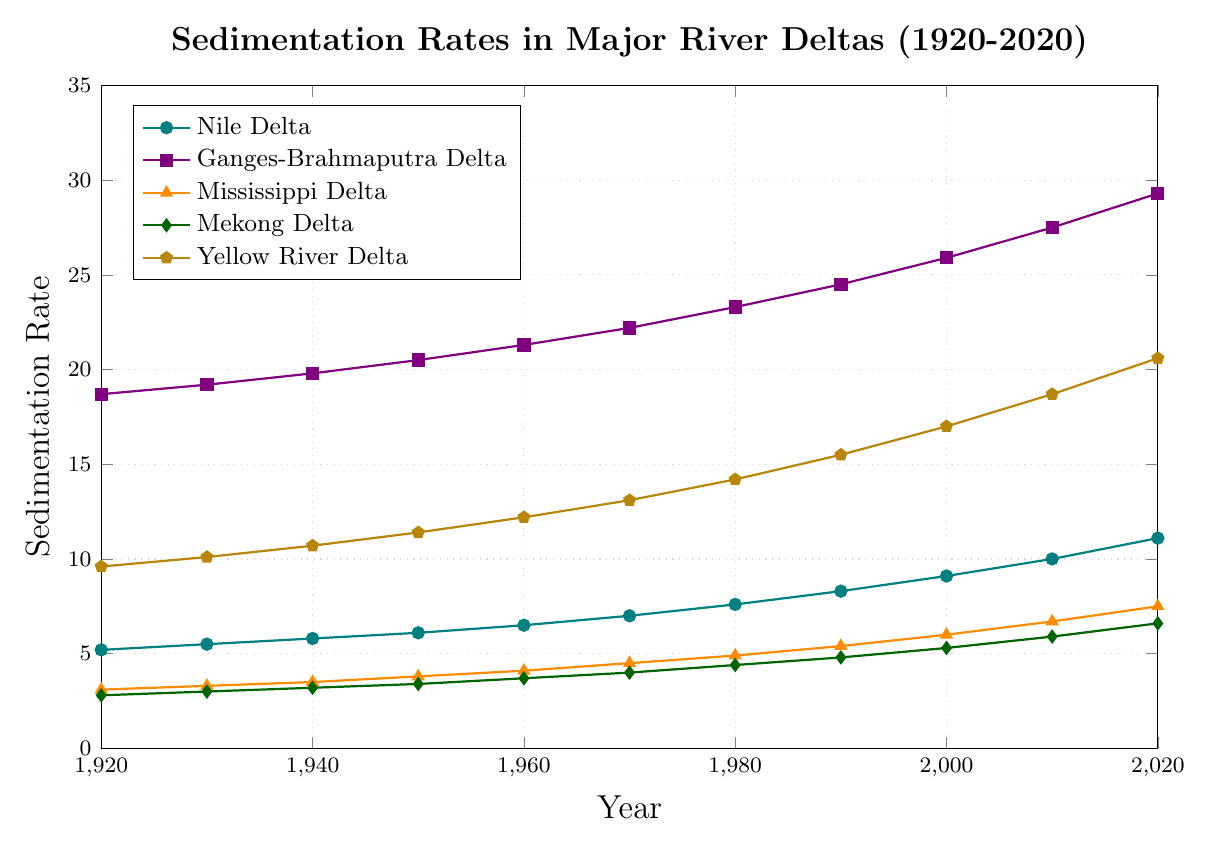Which river delta shows the highest sedimentation rate in 2020? From the figure, observe the point with the maximum sedimentation rate in 2020 and identify the corresponding river delta.
Answer: Yellow River Delta Compare the sedimentation rates of the Nile and Mekong Deltas in 1960. Which one is higher and by how much? Find the sedimentation rate for the Nile Delta in 1960, which is 6.5, and the Mekong Delta in 1960, which is 3.7. Subtract the Mekong rate from the Nile rate: 6.5 - 3.7.
Answer: Nile Delta by 2.8 By how much did the sedimentation rate of the Ganges-Brahmaputra Delta increase between 1920 and 2020? The sedimentation rate for the Ganges-Brahmaputra Delta in 1920 was 18.7 and in 2020 was 29.3. Subtract the 1920 rate from the 2020 rate: 29.3 - 18.7.
Answer: 10.6 Which river delta had the lowest sedimentation rate in 1940? From the figure, observe the points that correspond to the year 1940 and identify the lowest one.
Answer: Mekong Delta What is the average sedimentation rate for the Mississippi Delta from 1920 to 2020? Sum the rates for the Mississippi Delta at each decade (3.1, 3.3, 3.5, 3.8, 4.1, 4.5, 4.9, 5.4, 6.0, 6.7, 7.5) and divide by the number of data points, which is 11: (3.1 + 3.3 + 3.5 + 3.8 + 4.1 + 4.5 + 4.9 + 5.4 + 6.0 + 6.7 + 7.5) / 11.
Answer: 4.82 Compare the growth in sedimentation rates of the Yellow River Delta and the Nile Delta between 2000 and 2020. Which one had a larger increase? The increase for the Yellow River Delta between 2000 (17.0) and 2020 (20.6) is 20.6 - 17.0 = 3.6. The increase for the Nile Delta between 2000 (9.1) and 2020 (11.1) is 11.1 - 9.1 = 2.0. Compare these increases.
Answer: Yellow River Delta Among the deltas, which one shows the most consistent increase in sedimentation rate from 1920 to 2020? Observe the trends in the figure to identify the delta with a steady, consistent rise over time.
Answer: Ganges-Brahmaputra Delta What is the average sedimentation rate of all the river deltas in 1930? Add the sedimentation rates of all the deltas in 1930 and divide by the number of deltas: (5.5 + 19.2 + 3.3 + 3.0 + 10.1) / 5.
Answer: 8.22 